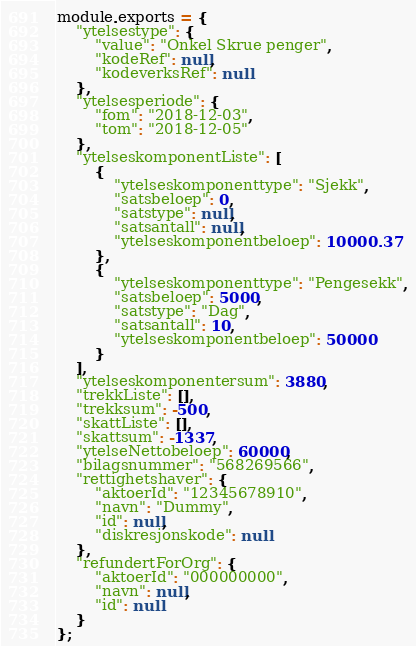Convert code to text. <code><loc_0><loc_0><loc_500><loc_500><_JavaScript_>module.exports = {
    "ytelsestype": {
        "value": "Onkel Skrue penger",
        "kodeRef": null,
        "kodeverksRef": null
    },
    "ytelsesperiode": {
        "fom": "2018-12-03",
        "tom": "2018-12-05"
    },
    "ytelseskomponentListe": [
        {
            "ytelseskomponenttype": "Sjekk",
            "satsbeloep": 0,
            "satstype": null,
            "satsantall": null,
            "ytelseskomponentbeloep": 10000.37
        },
        {
            "ytelseskomponenttype": "Pengesekk",
            "satsbeloep": 5000,
            "satstype": "Dag",
            "satsantall": 10,
            "ytelseskomponentbeloep": 50000
        }
    ],
    "ytelseskomponentersum": 3880,
    "trekkListe": [],
    "trekksum": -500,
    "skattListe": [],
    "skattsum": -1337,
    "ytelseNettobeloep": 60000,
    "bilagsnummer": "568269566",
    "rettighetshaver": {
        "aktoerId": "12345678910",
        "navn": "Dummy",
        "id": null,
        "diskresjonskode": null
    },
    "refundertForOrg": {
        "aktoerId": "000000000",
        "navn": null,
        "id": null
    }
};</code> 